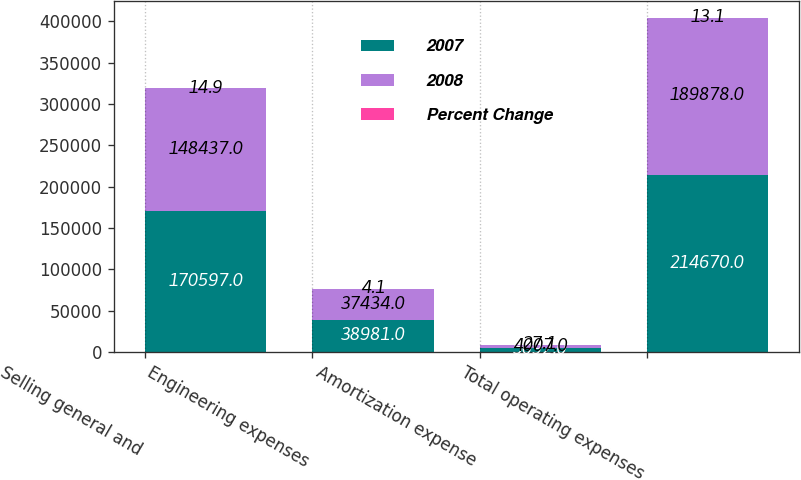Convert chart. <chart><loc_0><loc_0><loc_500><loc_500><stacked_bar_chart><ecel><fcel>Selling general and<fcel>Engineering expenses<fcel>Amortization expense<fcel>Total operating expenses<nl><fcel>2007<fcel>170597<fcel>38981<fcel>5092<fcel>214670<nl><fcel>2008<fcel>148437<fcel>37434<fcel>4007<fcel>189878<nl><fcel>Percent Change<fcel>14.9<fcel>4.1<fcel>27.1<fcel>13.1<nl></chart> 